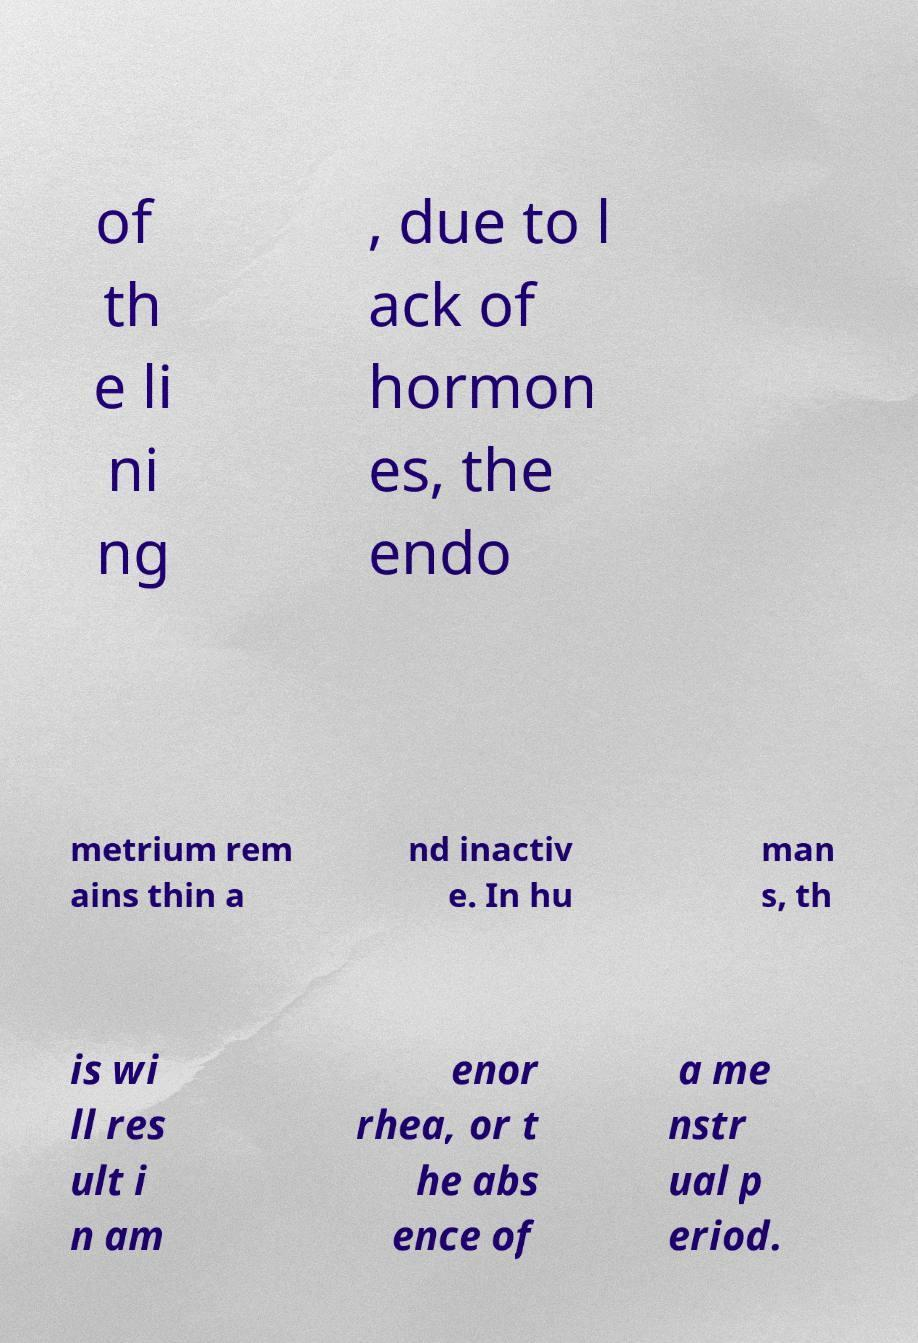What messages or text are displayed in this image? I need them in a readable, typed format. of th e li ni ng , due to l ack of hormon es, the endo metrium rem ains thin a nd inactiv e. In hu man s, th is wi ll res ult i n am enor rhea, or t he abs ence of a me nstr ual p eriod. 